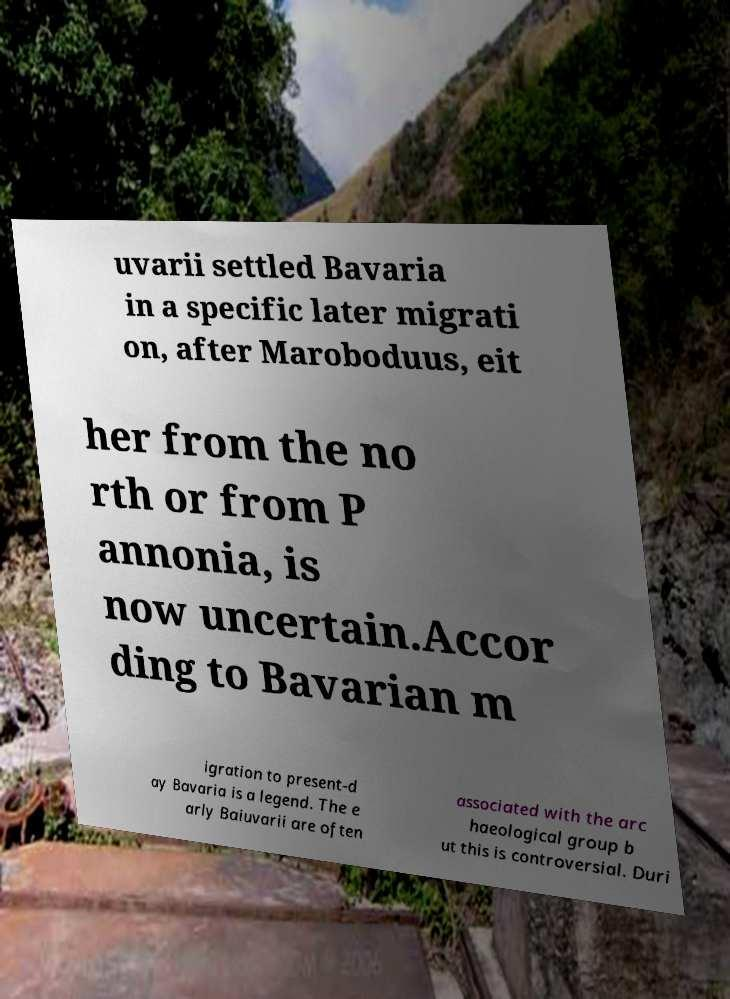Can you read and provide the text displayed in the image?This photo seems to have some interesting text. Can you extract and type it out for me? uvarii settled Bavaria in a specific later migrati on, after Maroboduus, eit her from the no rth or from P annonia, is now uncertain.Accor ding to Bavarian m igration to present-d ay Bavaria is a legend. The e arly Baiuvarii are often associated with the arc haeological group b ut this is controversial. Duri 